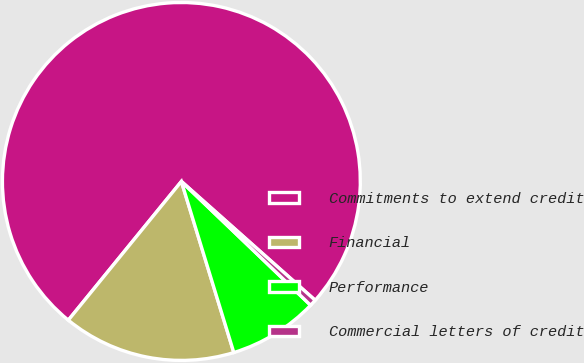<chart> <loc_0><loc_0><loc_500><loc_500><pie_chart><fcel>Commitments to extend credit<fcel>Financial<fcel>Performance<fcel>Commercial letters of credit<nl><fcel>75.68%<fcel>15.62%<fcel>8.11%<fcel>0.6%<nl></chart> 